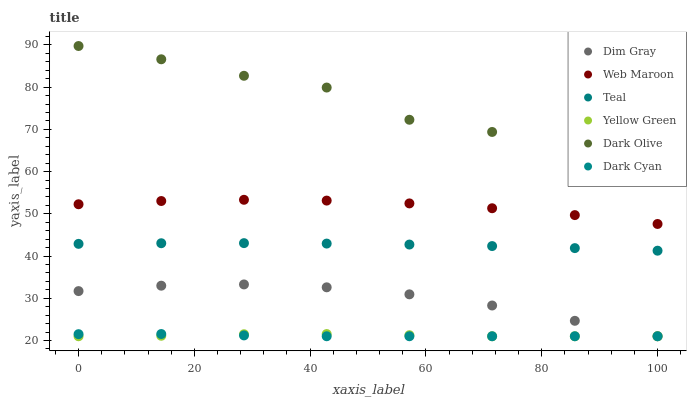Does Dark Cyan have the minimum area under the curve?
Answer yes or no. Yes. Does Dark Olive have the maximum area under the curve?
Answer yes or no. Yes. Does Yellow Green have the minimum area under the curve?
Answer yes or no. No. Does Yellow Green have the maximum area under the curve?
Answer yes or no. No. Is Dark Cyan the smoothest?
Answer yes or no. Yes. Is Dark Olive the roughest?
Answer yes or no. Yes. Is Yellow Green the smoothest?
Answer yes or no. No. Is Yellow Green the roughest?
Answer yes or no. No. Does Dim Gray have the lowest value?
Answer yes or no. Yes. Does Dark Olive have the lowest value?
Answer yes or no. No. Does Dark Olive have the highest value?
Answer yes or no. Yes. Does Yellow Green have the highest value?
Answer yes or no. No. Is Dark Cyan less than Dark Olive?
Answer yes or no. Yes. Is Dark Olive greater than Dim Gray?
Answer yes or no. Yes. Does Dim Gray intersect Dark Cyan?
Answer yes or no. Yes. Is Dim Gray less than Dark Cyan?
Answer yes or no. No. Is Dim Gray greater than Dark Cyan?
Answer yes or no. No. Does Dark Cyan intersect Dark Olive?
Answer yes or no. No. 